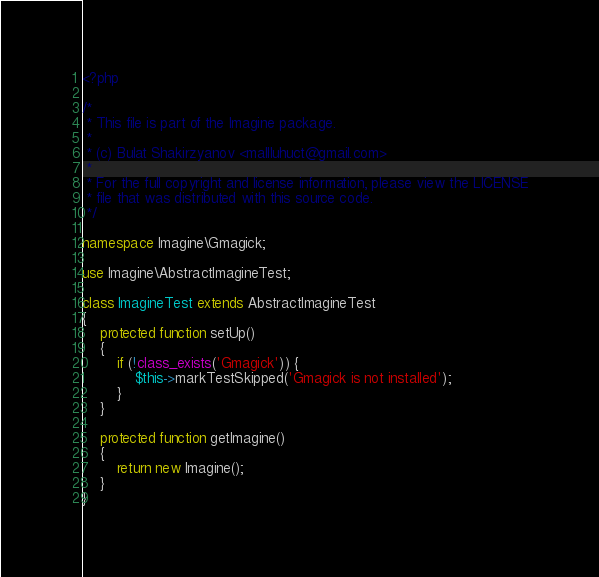<code> <loc_0><loc_0><loc_500><loc_500><_PHP_><?php

/*
 * This file is part of the Imagine package.
 *
 * (c) Bulat Shakirzyanov <mallluhuct@gmail.com>
 *
 * For the full copyright and license information, please view the LICENSE
 * file that was distributed with this source code.
 */

namespace Imagine\Gmagick;

use Imagine\AbstractImagineTest;

class ImagineTest extends AbstractImagineTest
{
    protected function setUp()
    {
        if (!class_exists('Gmagick')) {
            $this->markTestSkipped('Gmagick is not installed');
        }
    }

    protected function getImagine()
    {
        return new Imagine();
    }
}
</code> 